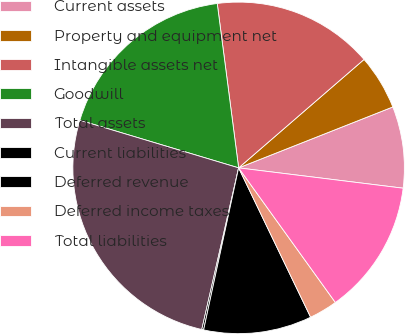<chart> <loc_0><loc_0><loc_500><loc_500><pie_chart><fcel>Current assets<fcel>Property and equipment net<fcel>Intangible assets net<fcel>Goodwill<fcel>Total assets<fcel>Current liabilities<fcel>Deferred revenue<fcel>Deferred income taxes<fcel>Total liabilities<nl><fcel>7.95%<fcel>5.36%<fcel>15.72%<fcel>18.31%<fcel>26.08%<fcel>0.18%<fcel>10.54%<fcel>2.77%<fcel>13.13%<nl></chart> 